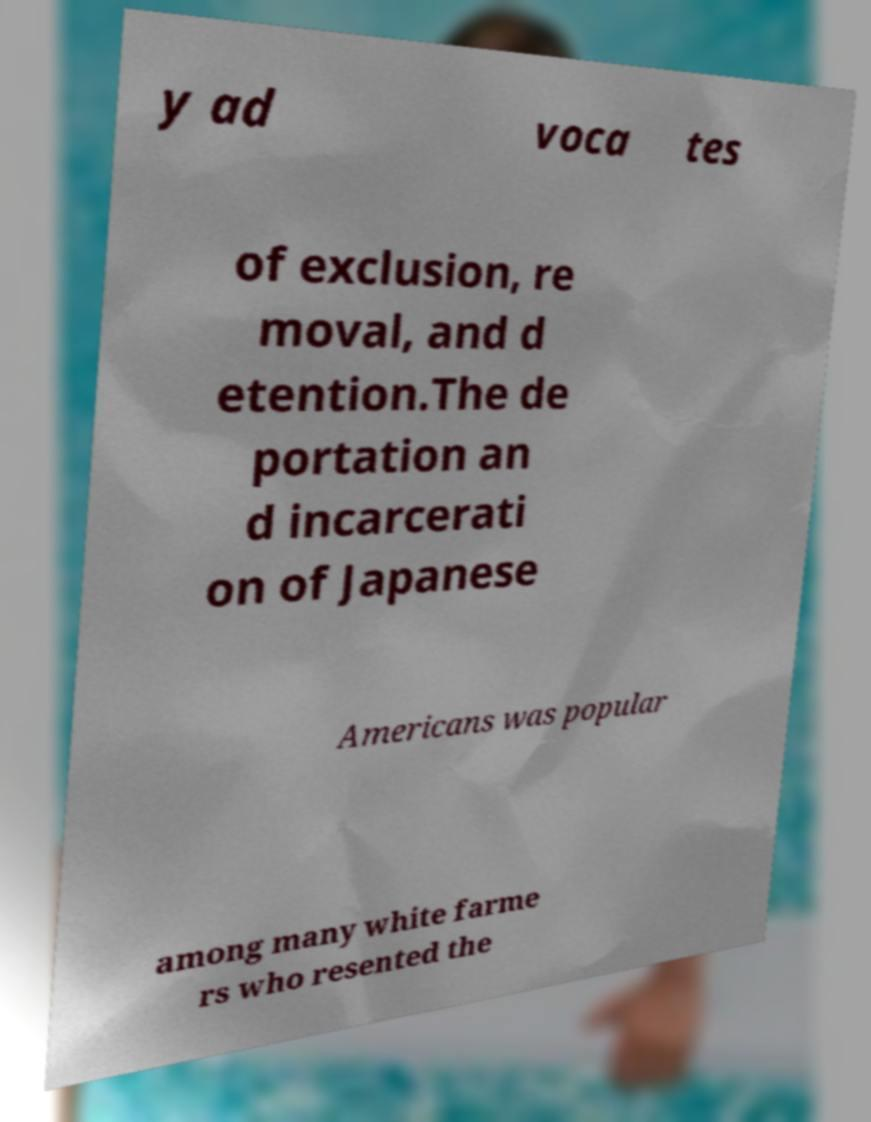There's text embedded in this image that I need extracted. Can you transcribe it verbatim? y ad voca tes of exclusion, re moval, and d etention.The de portation an d incarcerati on of Japanese Americans was popular among many white farme rs who resented the 